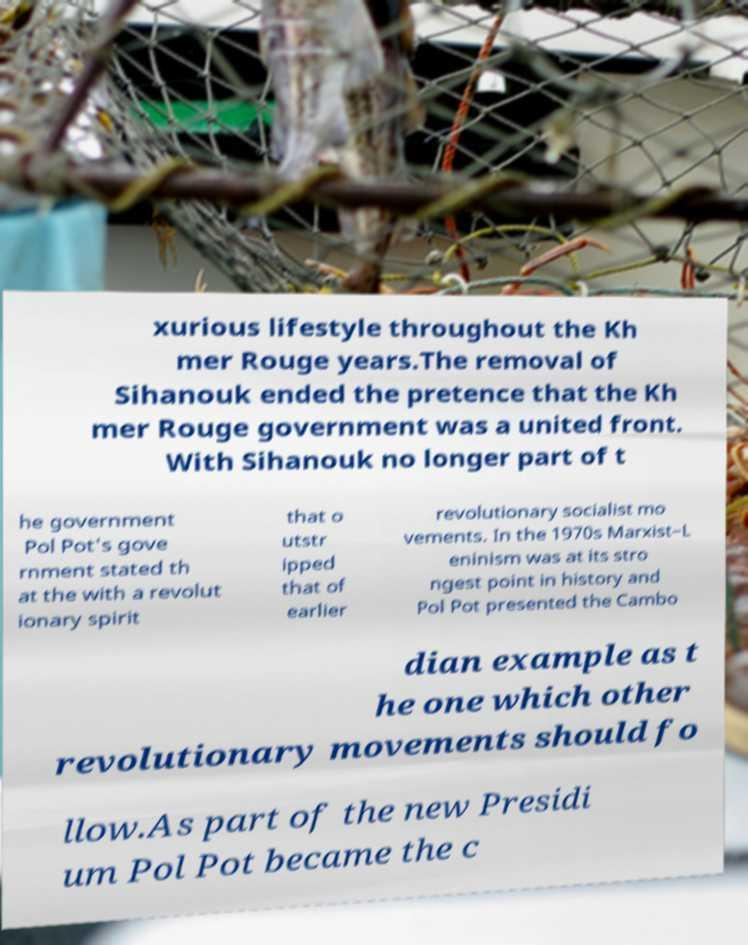Please read and relay the text visible in this image. What does it say? xurious lifestyle throughout the Kh mer Rouge years.The removal of Sihanouk ended the pretence that the Kh mer Rouge government was a united front. With Sihanouk no longer part of t he government Pol Pot's gove rnment stated th at the with a revolut ionary spirit that o utstr ipped that of earlier revolutionary socialist mo vements. In the 1970s Marxist–L eninism was at its stro ngest point in history and Pol Pot presented the Cambo dian example as t he one which other revolutionary movements should fo llow.As part of the new Presidi um Pol Pot became the c 